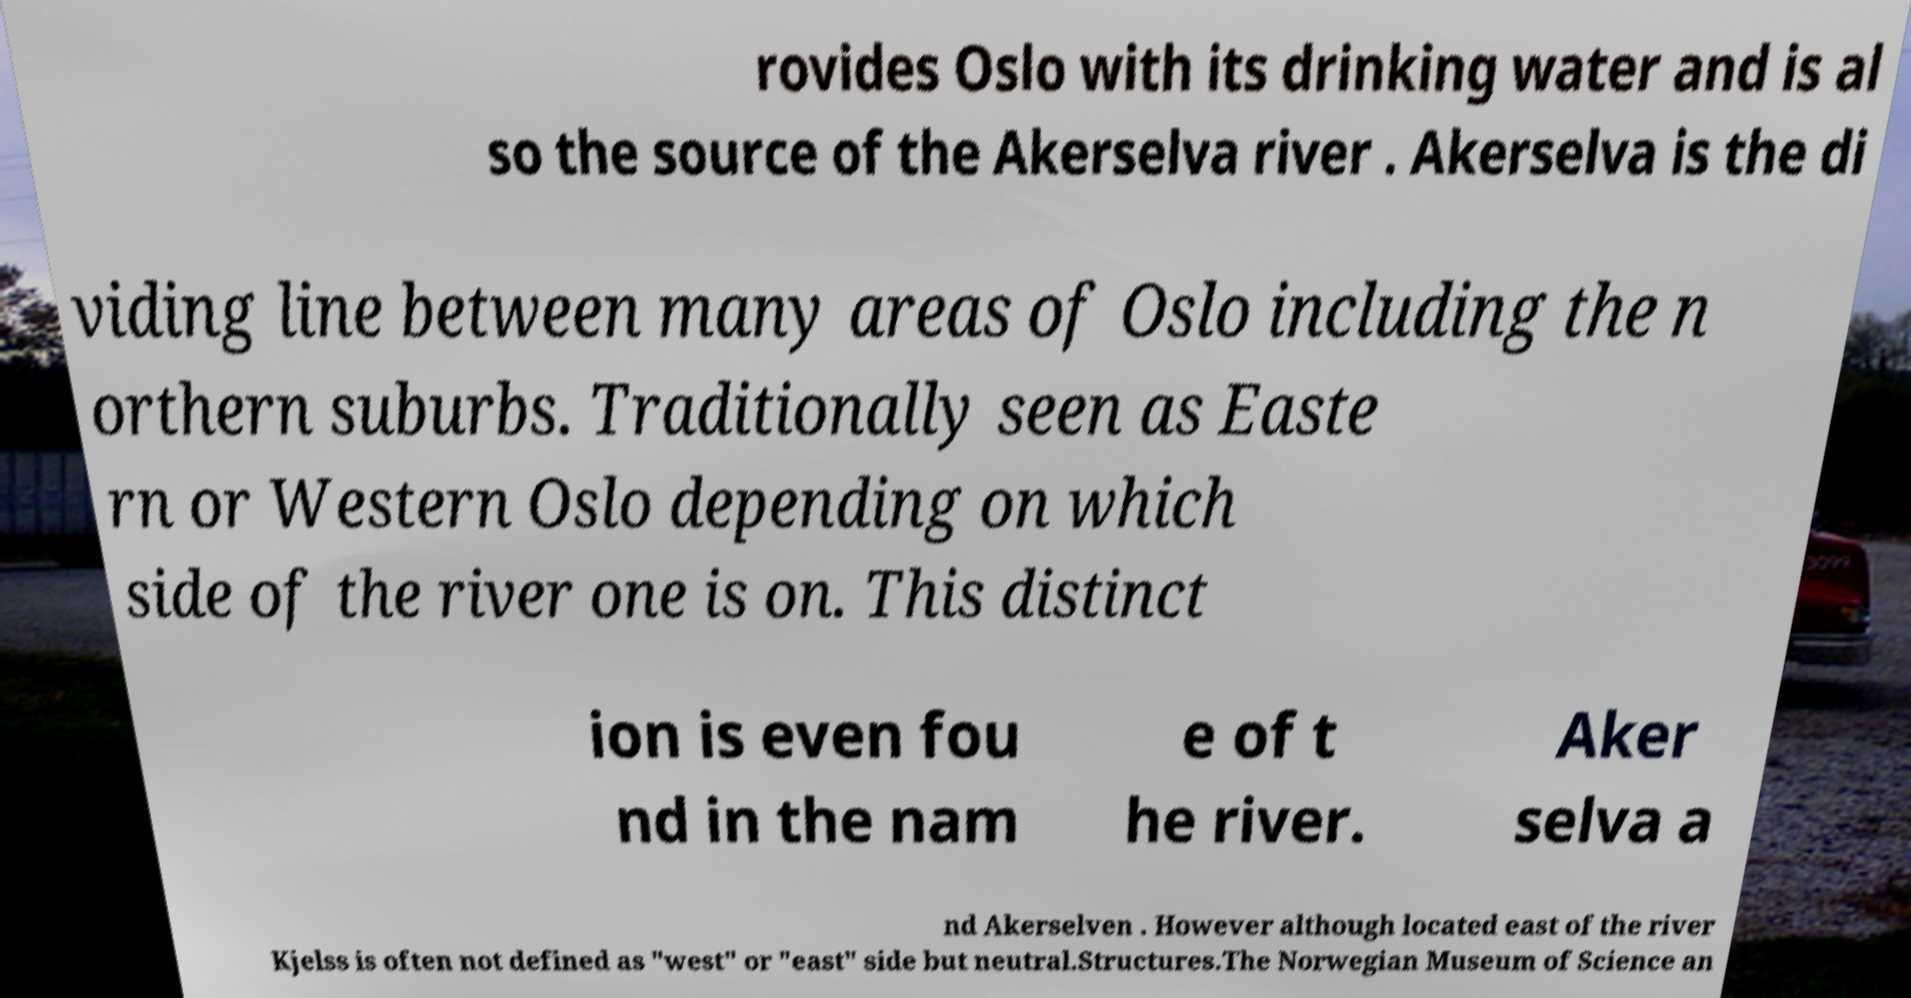Could you assist in decoding the text presented in this image and type it out clearly? rovides Oslo with its drinking water and is al so the source of the Akerselva river . Akerselva is the di viding line between many areas of Oslo including the n orthern suburbs. Traditionally seen as Easte rn or Western Oslo depending on which side of the river one is on. This distinct ion is even fou nd in the nam e of t he river. Aker selva a nd Akerselven . However although located east of the river Kjelss is often not defined as "west" or "east" side but neutral.Structures.The Norwegian Museum of Science an 